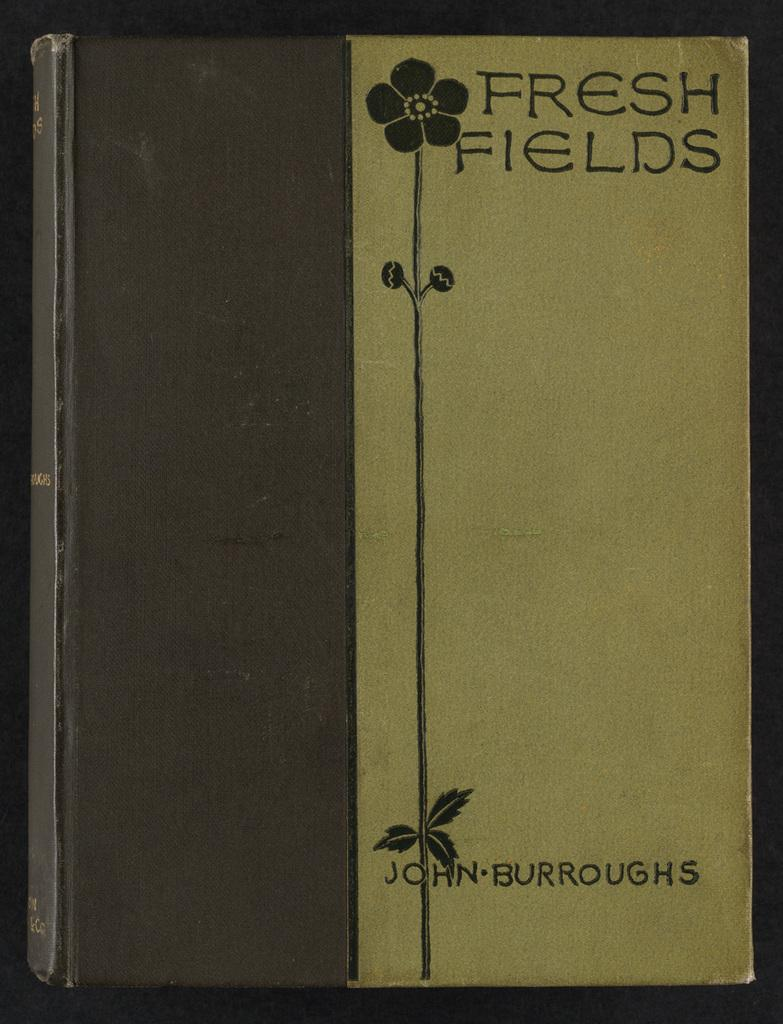<image>
Summarize the visual content of the image. The cover of a book called Fresh Fields is brown and cream colored 